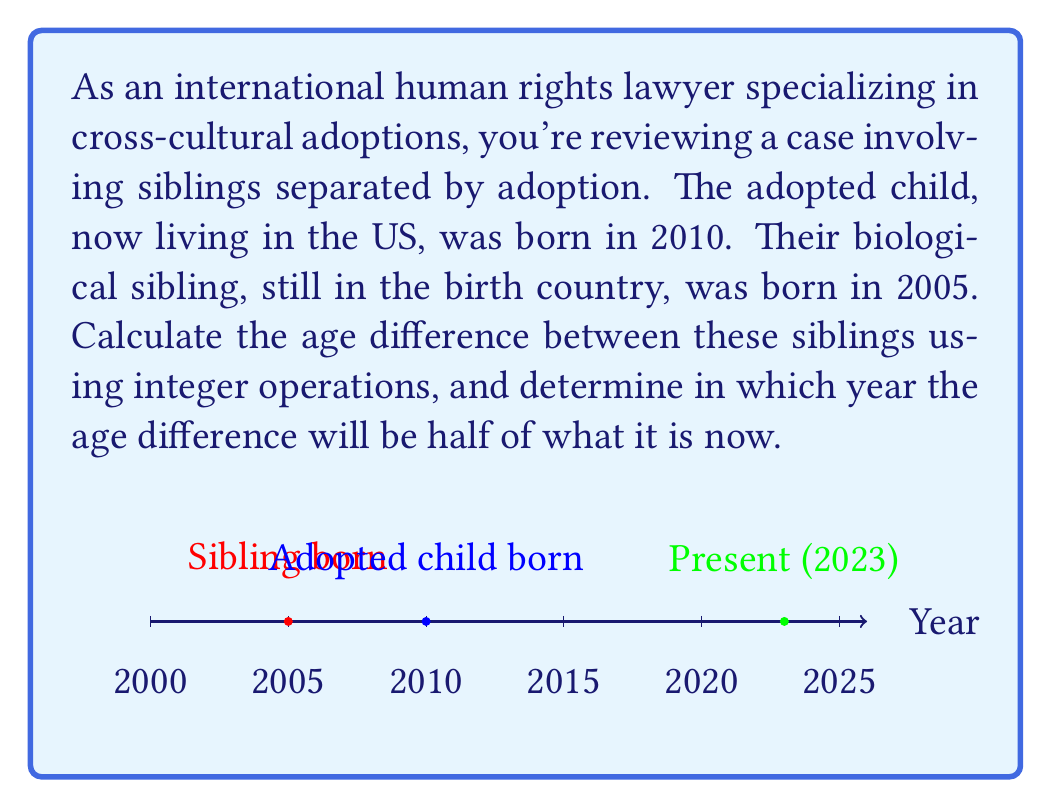Teach me how to tackle this problem. Let's approach this step-by-step:

1) First, calculate the current age difference:
   $$ \text{Age difference} = 2010 - 2005 = 5 \text{ years} $$

2) Now, we need to find when this difference will be half of what it is now. Let's call the future year $x$.
   
3) In year $x$, the age difference will be:
   $$ \text{Future age difference} = (x - 2005) - (x - 2010) = 5 \text{ years} $$
   
4) We want this future age difference to be half of the current difference:
   $$ \frac{5}{2} = 2.5 \text{ years} $$

5) Set up an equation:
   $$ (x - 2005) - (x - 2010) = 2.5 $$

6) Simplify:
   $$ 2010 - 2005 = 2.5 $$
   $$ 5 = 2.5 $$

7) This equation is always true, which means the age difference will always be 5 years and never be half of what it is now.

8) However, we can calculate when the younger sibling will be half the age of the older sibling:
   $$ \frac{x - 2010}{x - 2005} = \frac{1}{2} $$

9) Cross multiply:
   $$ 2(x - 2010) = x - 2005 $$

10) Expand:
    $$ 2x - 4020 = x - 2005 $$

11) Subtract $x$ from both sides:
    $$ x - 4020 = -2005 $$

12) Add 4020 to both sides:
    $$ x = 2015 $$

Therefore, in 2015, the younger sibling was half the age of the older sibling.
Answer: 5 years; 2015 